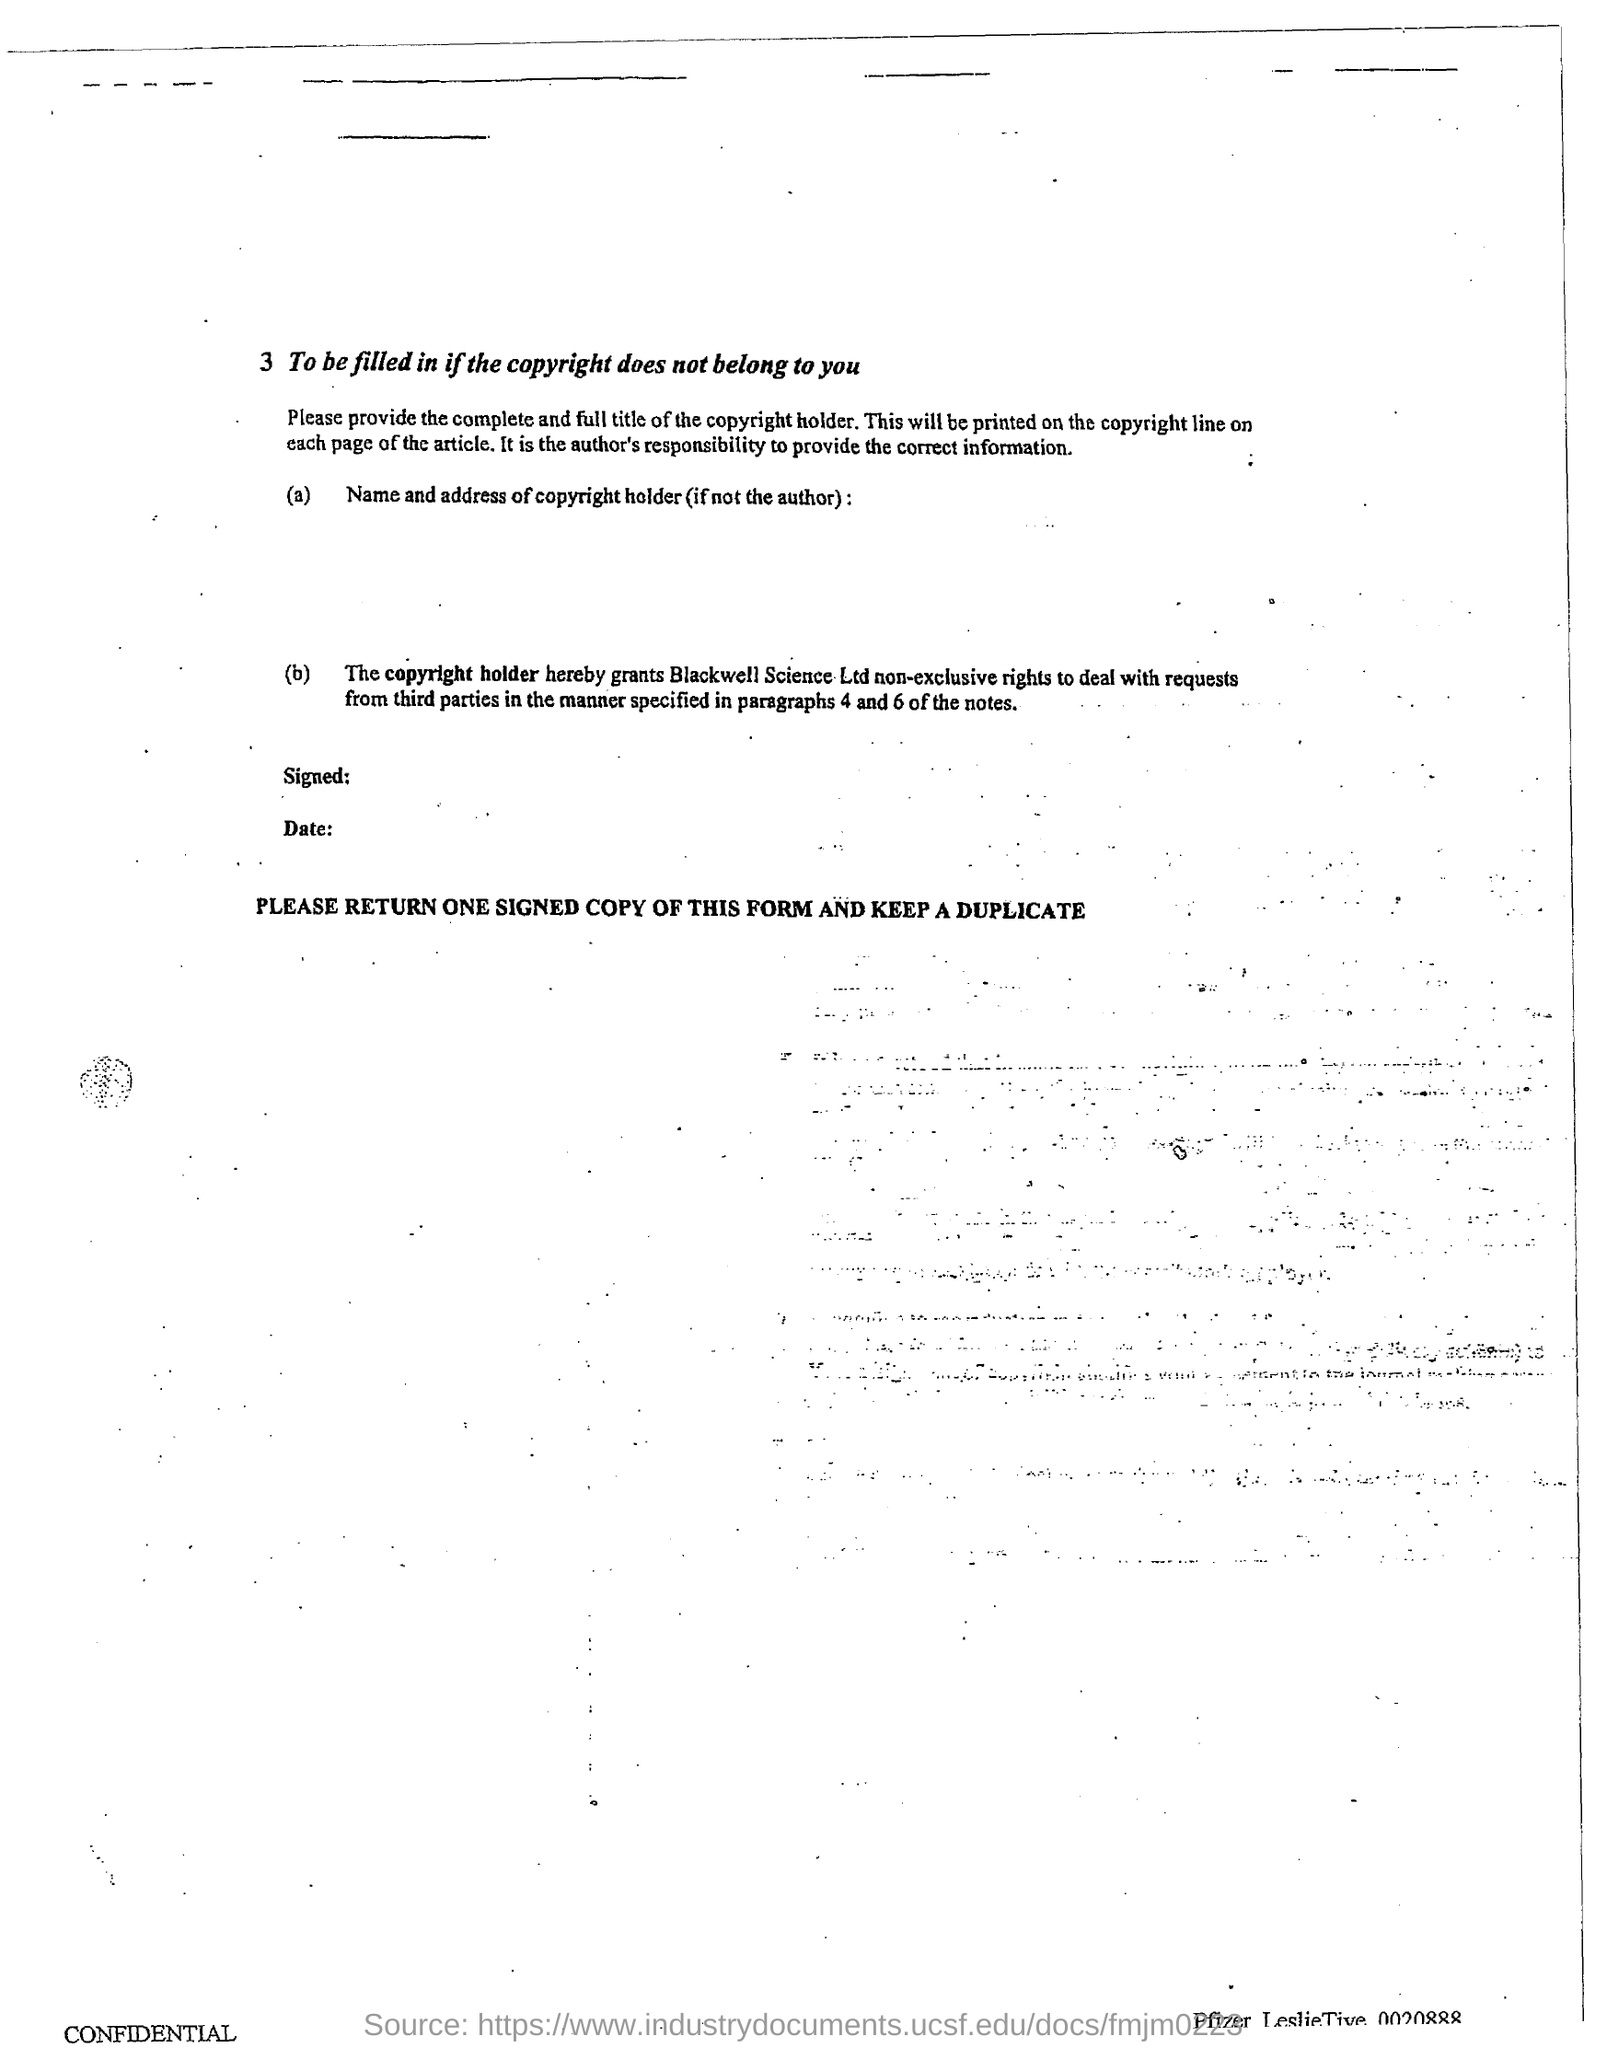Specify some key components in this picture. The copyright holder grants non-exclusive rights to Blackwell Science Ltd to deal with requests from third parties. It is the responsibility of the author to provide accurate and reliable information. 